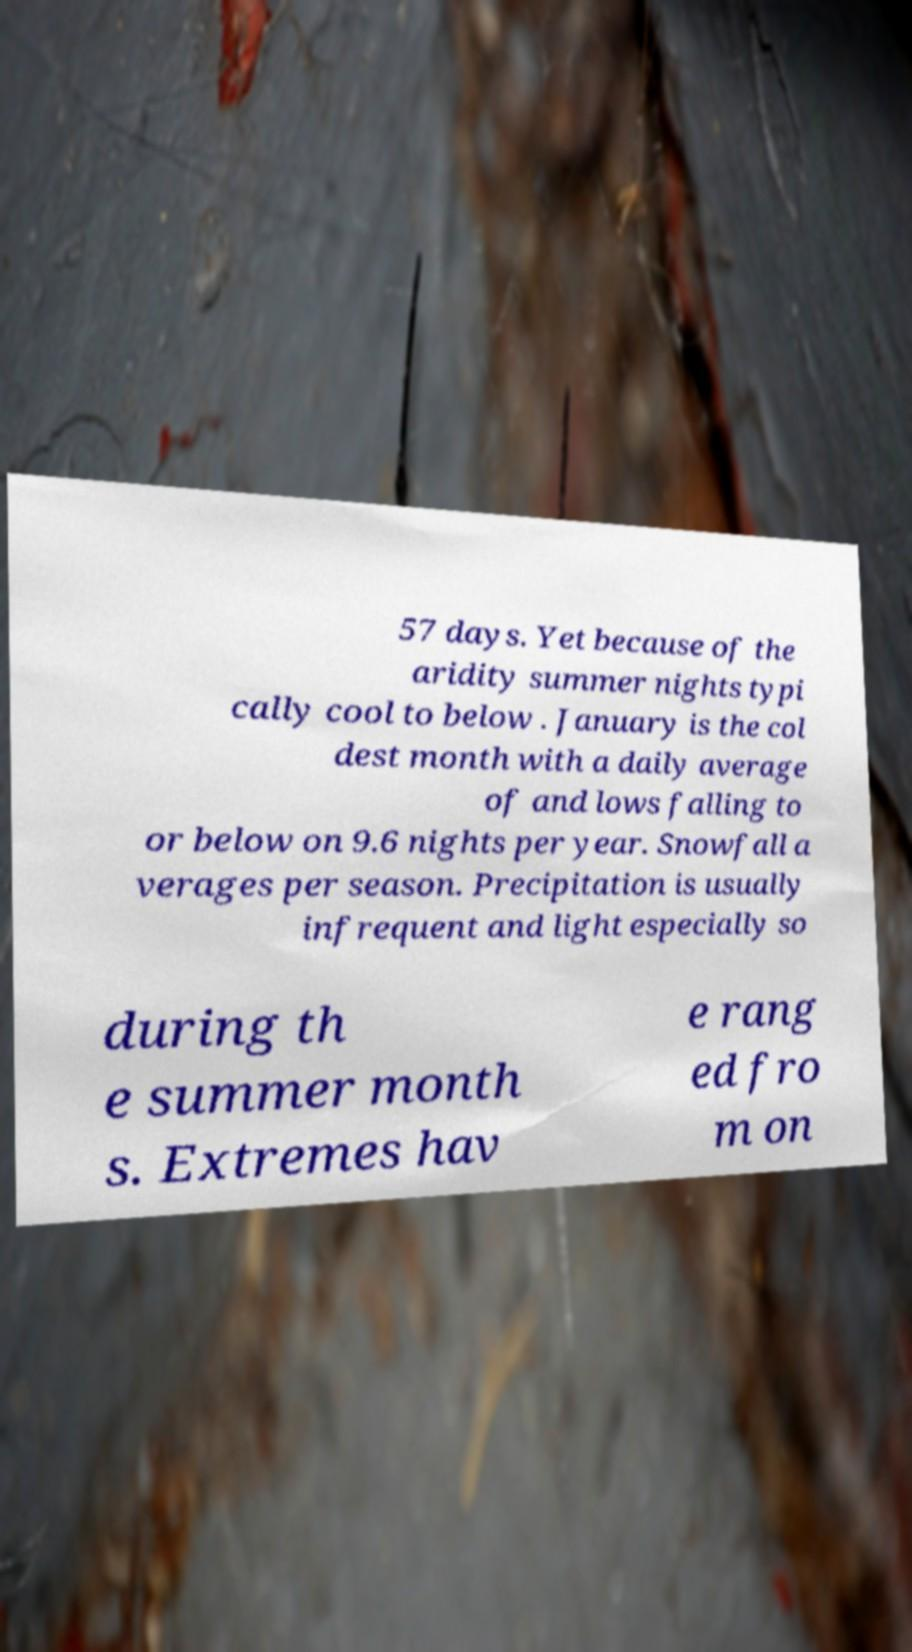I need the written content from this picture converted into text. Can you do that? 57 days. Yet because of the aridity summer nights typi cally cool to below . January is the col dest month with a daily average of and lows falling to or below on 9.6 nights per year. Snowfall a verages per season. Precipitation is usually infrequent and light especially so during th e summer month s. Extremes hav e rang ed fro m on 